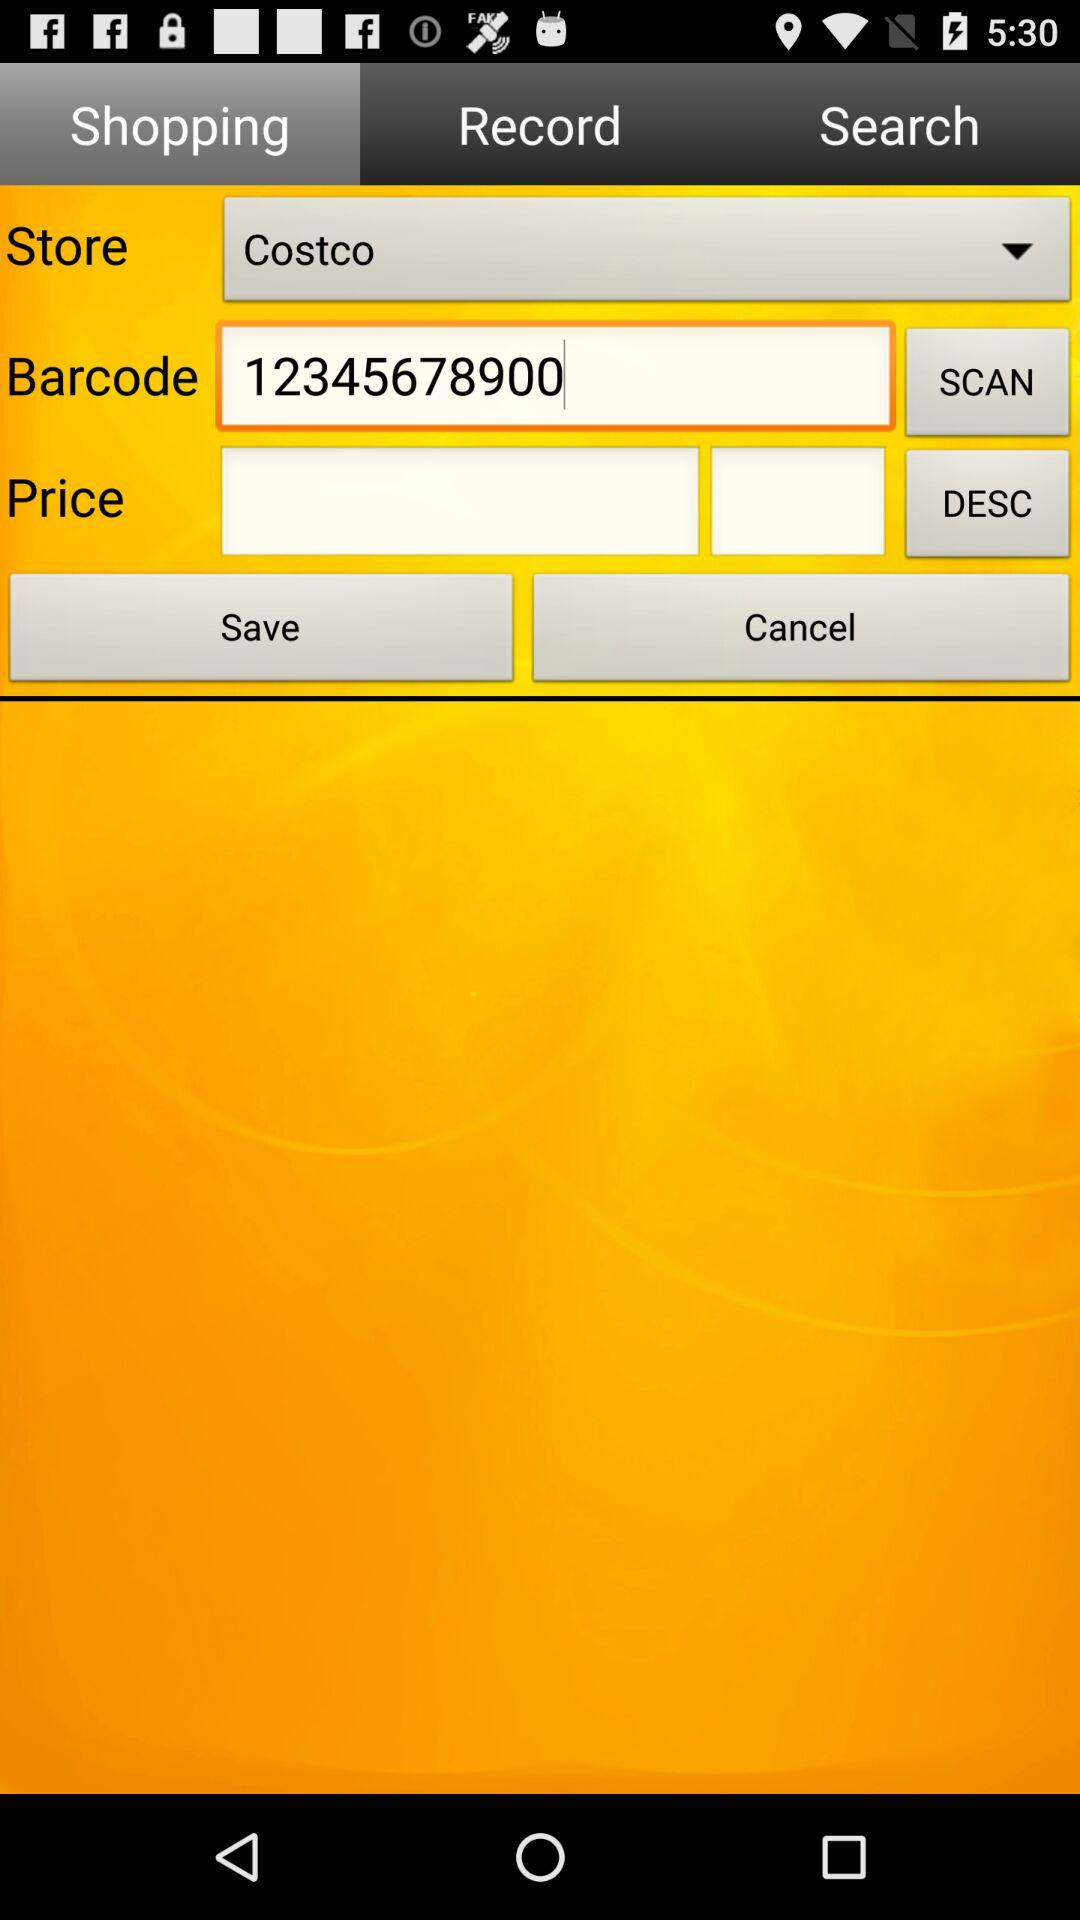What is the barcode? The barcode is 12345678900. 